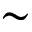Convert formula to latex. <formula><loc_0><loc_0><loc_500><loc_500>\sim</formula> 